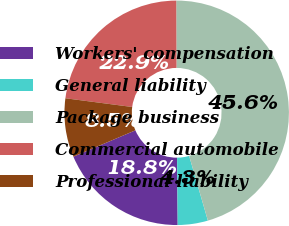<chart> <loc_0><loc_0><loc_500><loc_500><pie_chart><fcel>Workers' compensation<fcel>General liability<fcel>Package business<fcel>Commercial automobile<fcel>Professional liability<nl><fcel>18.75%<fcel>4.34%<fcel>45.58%<fcel>22.87%<fcel>8.46%<nl></chart> 